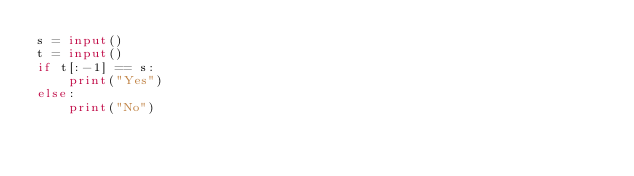Convert code to text. <code><loc_0><loc_0><loc_500><loc_500><_Python_>s = input()
t = input()
if t[:-1] == s:
    print("Yes")
else:
    print("No")</code> 